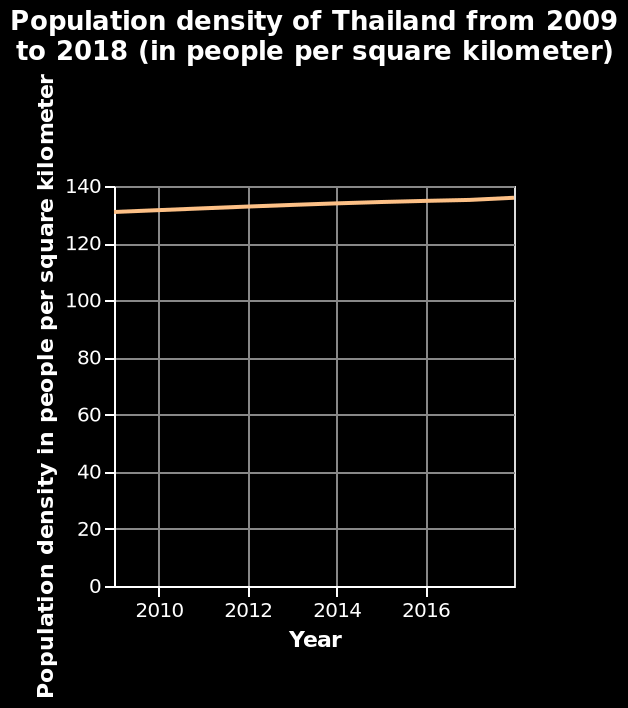<image>
please enumerates aspects of the construction of the chart Population density of Thailand from 2009 to 2018 (in people per square kilometer) is a line diagram. There is a linear scale with a minimum of 2010 and a maximum of 2016 along the x-axis, marked Year. There is a linear scale from 0 to 140 along the y-axis, marked Population density in people per square kilometer. What is the trend of Thailand's population density between 2010 and 2016? The trend of Thailand's population density between 2010 and 2016 has been steady increase. 